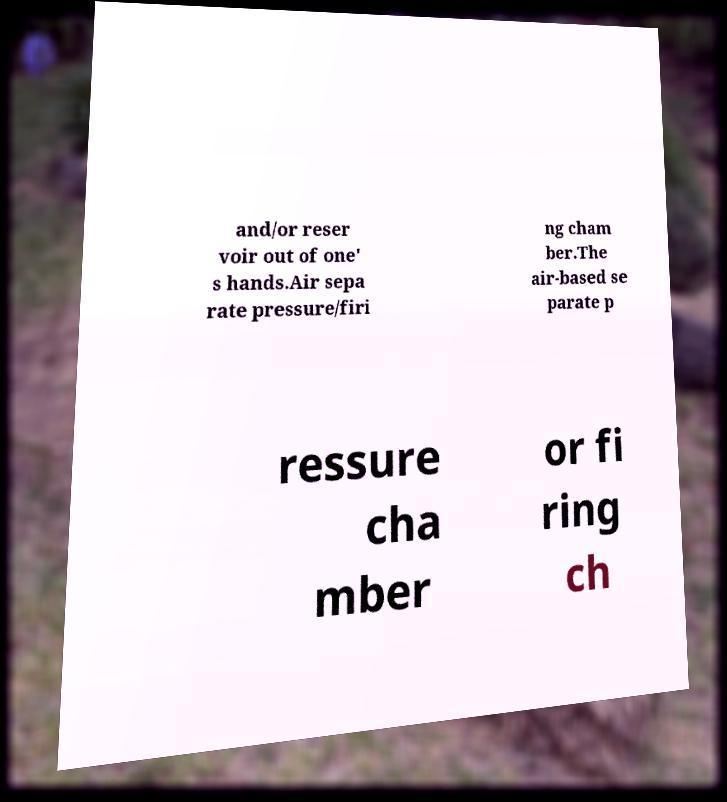For documentation purposes, I need the text within this image transcribed. Could you provide that? and/or reser voir out of one' s hands.Air sepa rate pressure/firi ng cham ber.The air-based se parate p ressure cha mber or fi ring ch 